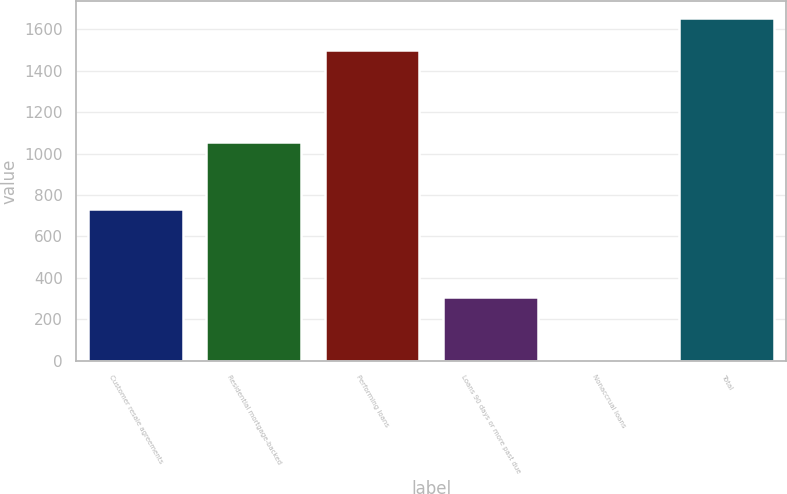Convert chart to OTSL. <chart><loc_0><loc_0><loc_500><loc_500><bar_chart><fcel>Customer resale agreements<fcel>Residential mortgage-backed<fcel>Performing loans<fcel>Loans 90 days or more past due<fcel>Nonaccrual loans<fcel>Total<nl><fcel>732<fcel>1058<fcel>1501<fcel>306<fcel>2<fcel>1653<nl></chart> 